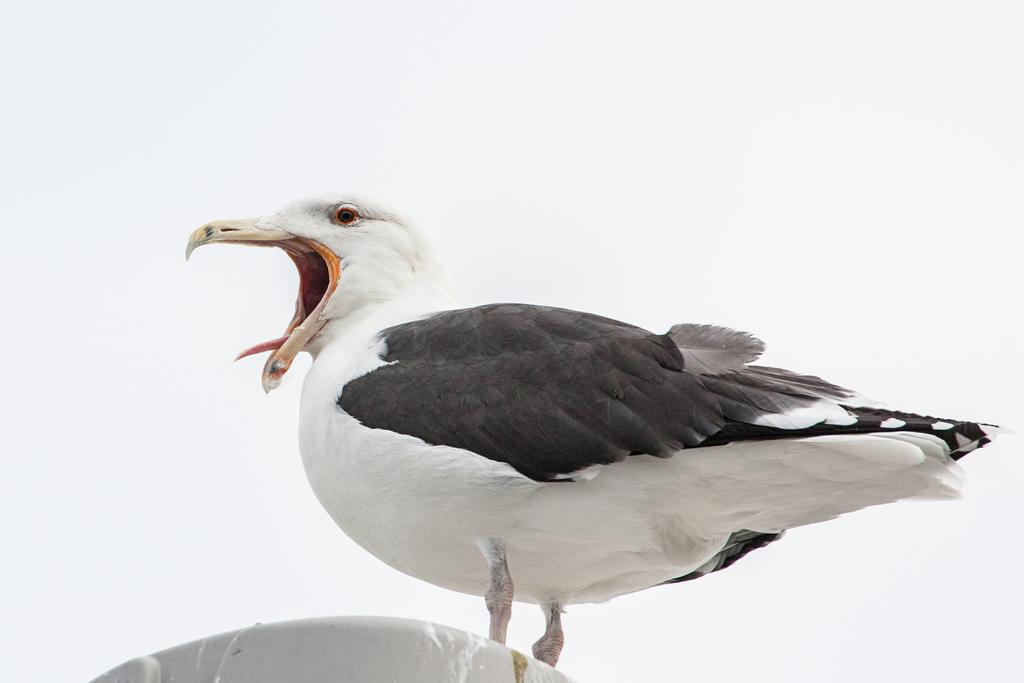What type of bird can be seen in the image? There is a black and white bird in the image. What is the bird doing in the image? The bird's mouth is open. What can be seen at the bottom of the image? There is a white object at the bottom of the image. What is visible in the background of the image? The sky is visible in the background of the image. What type of joke is the bird telling in the image? There is no indication in the image that the bird is telling a joke, as it is simply depicted with its mouth open. How many rabbits can be seen in the image? There are no rabbits present in the image; it features a black and white bird. 